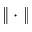<formula> <loc_0><loc_0><loc_500><loc_500>\| \cdot \|</formula> 